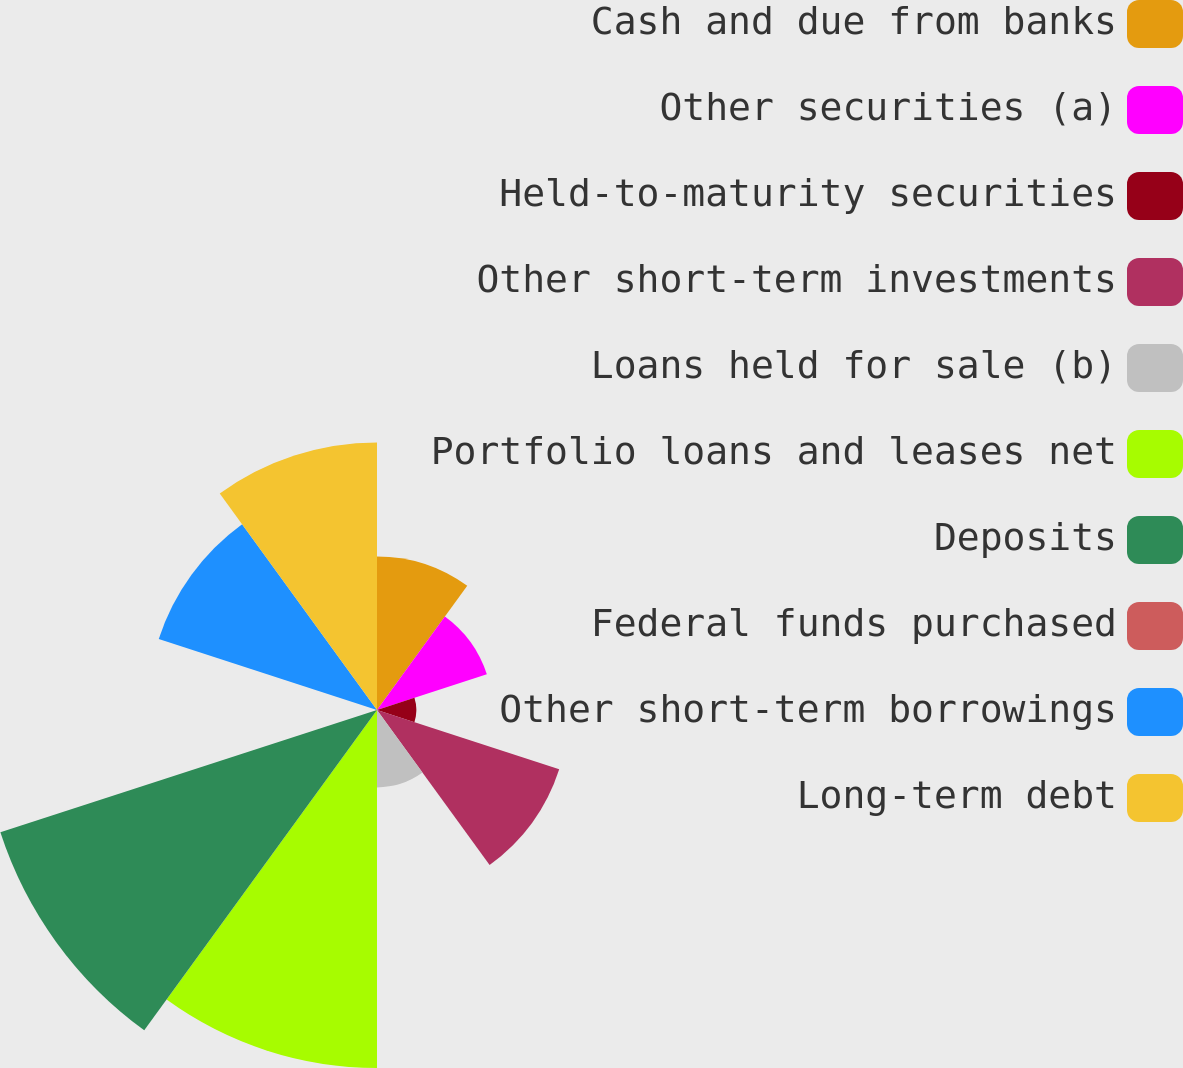Convert chart to OTSL. <chart><loc_0><loc_0><loc_500><loc_500><pie_chart><fcel>Cash and due from banks<fcel>Other securities (a)<fcel>Held-to-maturity securities<fcel>Other short-term investments<fcel>Loans held for sale (b)<fcel>Portfolio loans and leases net<fcel>Deposits<fcel>Federal funds purchased<fcel>Other short-term borrowings<fcel>Long-term debt<nl><fcel>8.39%<fcel>6.31%<fcel>2.15%<fcel>10.47%<fcel>4.23%<fcel>19.56%<fcel>21.64%<fcel>0.08%<fcel>12.54%<fcel>14.62%<nl></chart> 